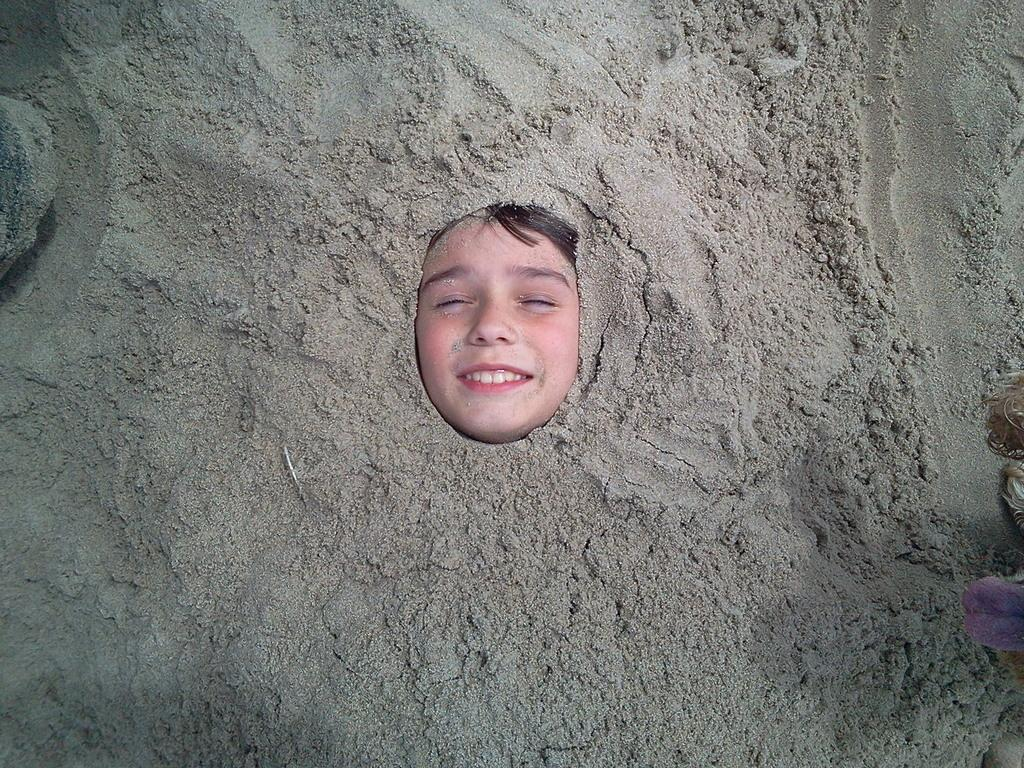Who or what can be seen in the image? There is a person in the image. What is the environment like around the person? There is sand surrounding the person. What type of stone is the person using to engage in an argument in the image? There is no stone or argument present in the image; it only features a person surrounded by sand. 